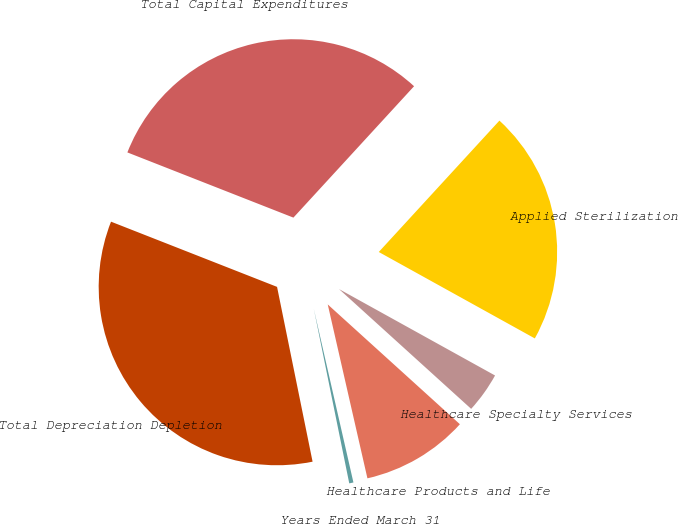Convert chart. <chart><loc_0><loc_0><loc_500><loc_500><pie_chart><fcel>Years Ended March 31<fcel>Healthcare Products and Life<fcel>Healthcare Specialty Services<fcel>Applied Sterilization<fcel>Total Capital Expenditures<fcel>Total Depreciation Depletion<nl><fcel>0.38%<fcel>9.71%<fcel>3.67%<fcel>21.23%<fcel>30.87%<fcel>34.15%<nl></chart> 